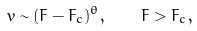Convert formula to latex. <formula><loc_0><loc_0><loc_500><loc_500>v \sim ( F - F _ { c } ) ^ { \theta } , \quad F > F _ { c } ,</formula> 